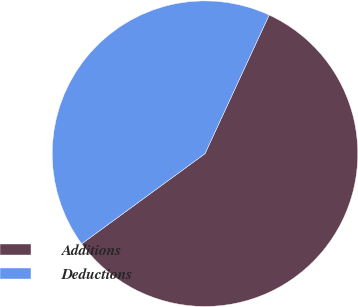Convert chart to OTSL. <chart><loc_0><loc_0><loc_500><loc_500><pie_chart><fcel>Additions<fcel>Deductions<nl><fcel>58.06%<fcel>41.94%<nl></chart> 